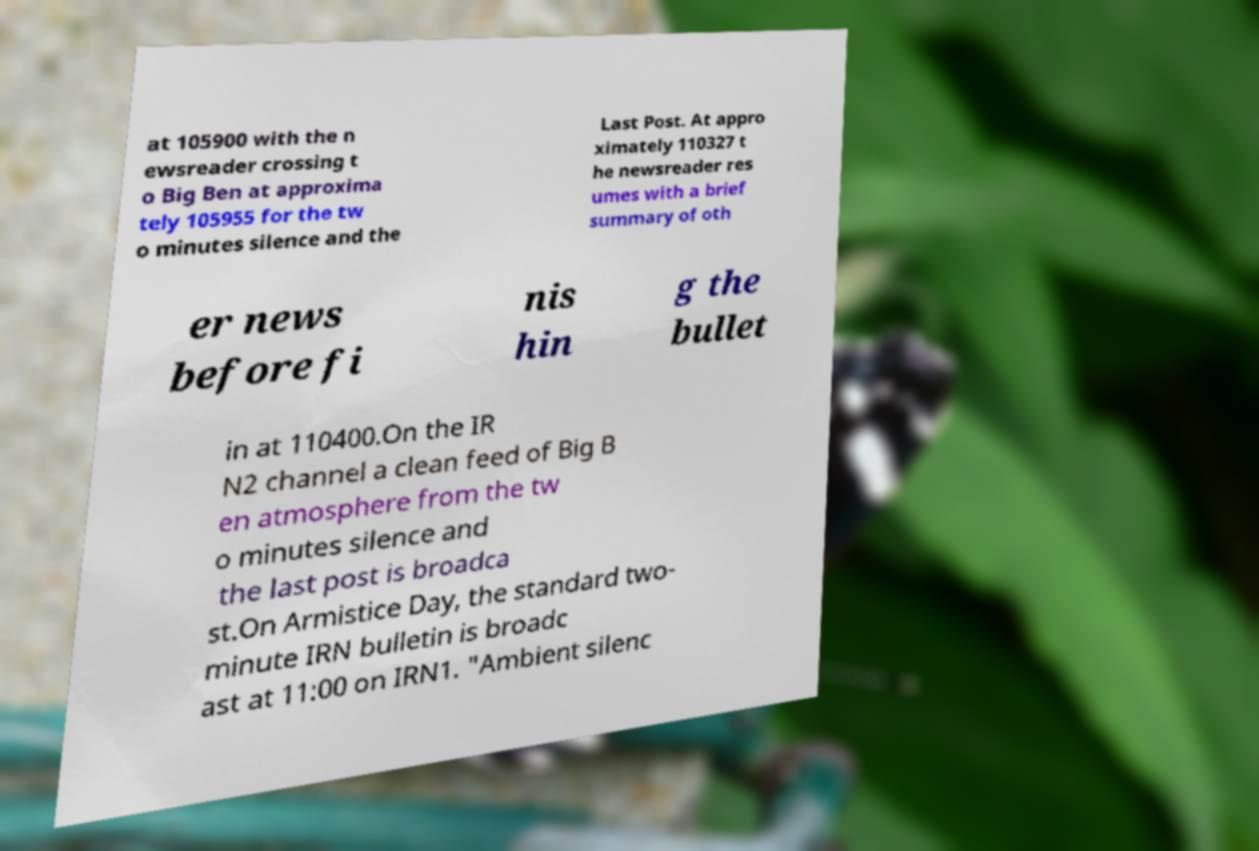Can you accurately transcribe the text from the provided image for me? at 105900 with the n ewsreader crossing t o Big Ben at approxima tely 105955 for the tw o minutes silence and the Last Post. At appro ximately 110327 t he newsreader res umes with a brief summary of oth er news before fi nis hin g the bullet in at 110400.On the IR N2 channel a clean feed of Big B en atmosphere from the tw o minutes silence and the last post is broadca st.On Armistice Day, the standard two- minute IRN bulletin is broadc ast at 11:00 on IRN1. "Ambient silenc 